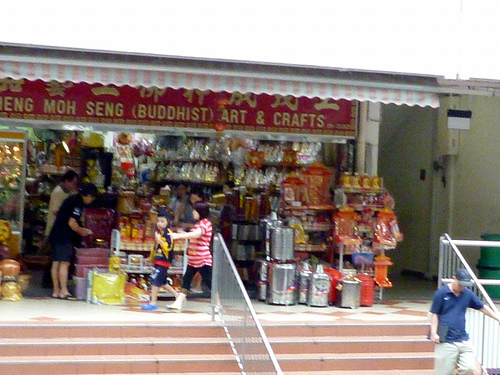<image>
Can you confirm if the person is in front of the man? Yes. The person is positioned in front of the man, appearing closer to the camera viewpoint. 